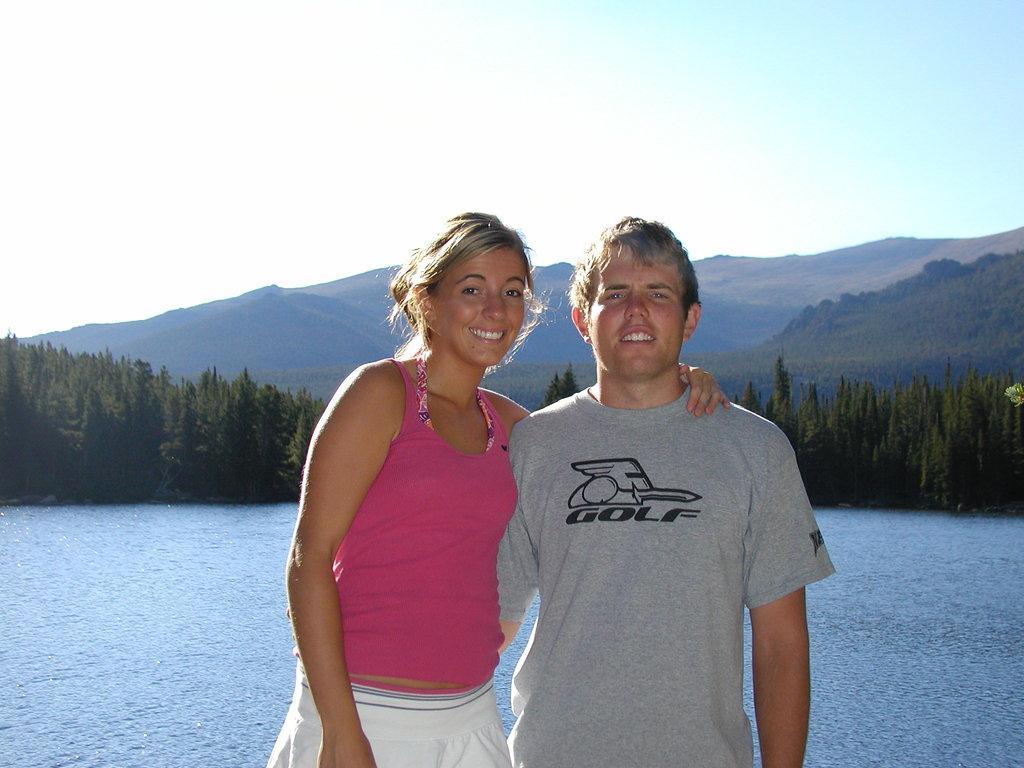Could you give a brief overview of what you see in this image? A man is standing, he wore t-shirt beside him a woman is standing, she wore pink color top, behind them there is water. At the long back side there are trees, at the top it is the sky. 